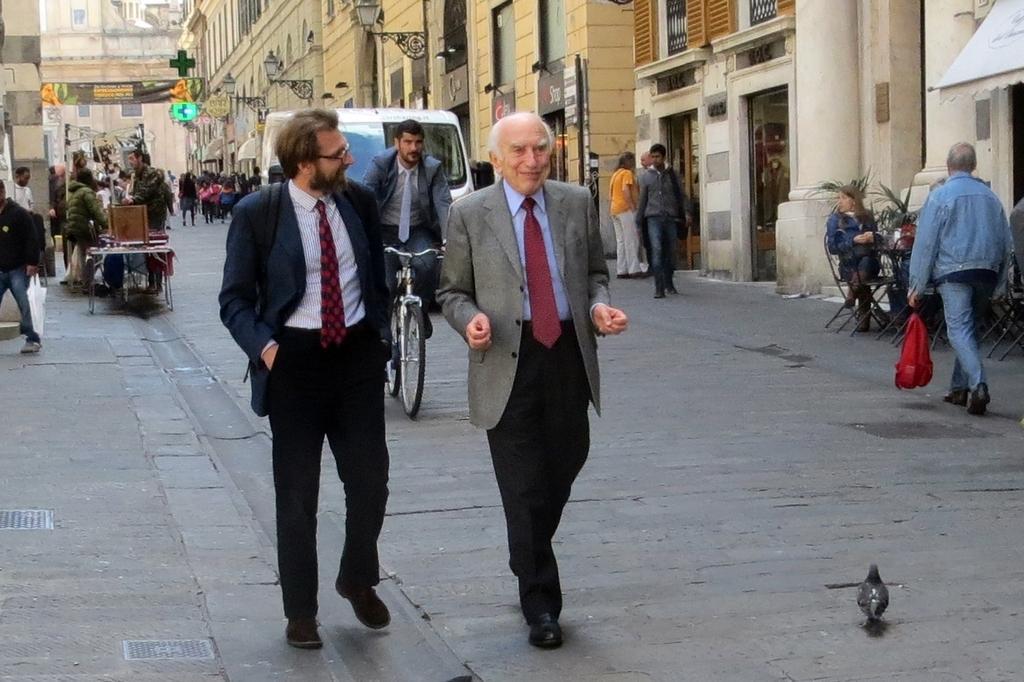Please provide a concise description of this image. In this image we can see some persons walking through the walkway in the foreground of the image there are two persons wearing suits walking together and in the background of the image there are some persons riding bicycles, driving cars, there are some buildings on left and right side of the image. 